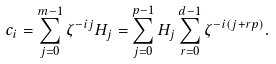Convert formula to latex. <formula><loc_0><loc_0><loc_500><loc_500>c _ { i } = \sum _ { j = 0 } ^ { m - 1 } \zeta ^ { - i j } H _ { j } = \sum _ { j = 0 } ^ { p - 1 } H _ { j } \sum _ { r = 0 } ^ { d - 1 } \zeta ^ { - i ( j + r p ) } .</formula> 